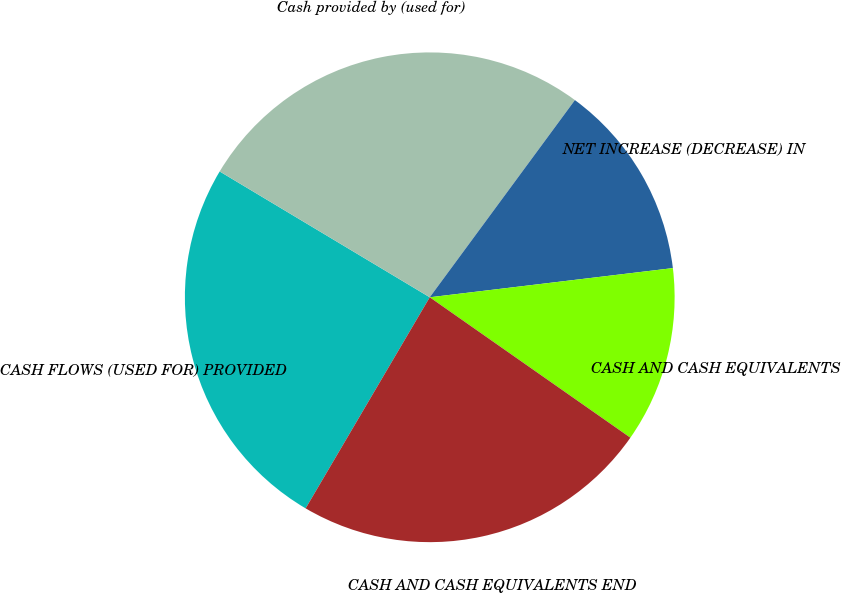<chart> <loc_0><loc_0><loc_500><loc_500><pie_chart><fcel>CASH FLOWS (USED FOR) PROVIDED<fcel>Cash provided by (used for)<fcel>NET INCREASE (DECREASE) IN<fcel>CASH AND CASH EQUIVALENTS<fcel>CASH AND CASH EQUIVALENTS END<nl><fcel>25.13%<fcel>26.51%<fcel>13.0%<fcel>11.62%<fcel>23.74%<nl></chart> 